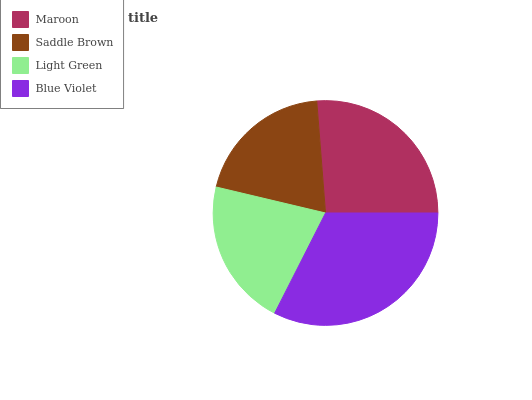Is Saddle Brown the minimum?
Answer yes or no. Yes. Is Blue Violet the maximum?
Answer yes or no. Yes. Is Light Green the minimum?
Answer yes or no. No. Is Light Green the maximum?
Answer yes or no. No. Is Light Green greater than Saddle Brown?
Answer yes or no. Yes. Is Saddle Brown less than Light Green?
Answer yes or no. Yes. Is Saddle Brown greater than Light Green?
Answer yes or no. No. Is Light Green less than Saddle Brown?
Answer yes or no. No. Is Maroon the high median?
Answer yes or no. Yes. Is Light Green the low median?
Answer yes or no. Yes. Is Blue Violet the high median?
Answer yes or no. No. Is Maroon the low median?
Answer yes or no. No. 